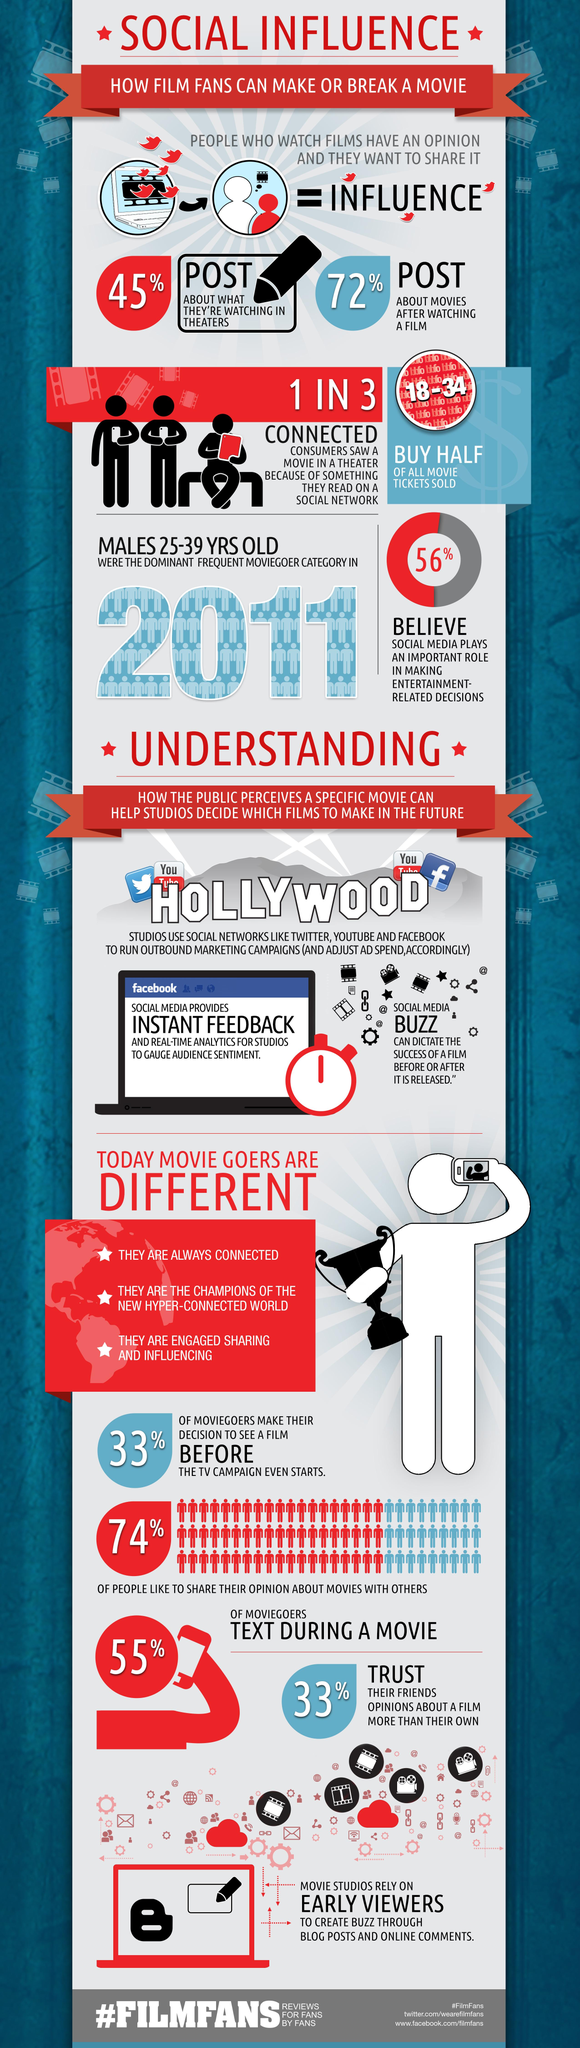Highlight a few significant elements in this photo. The 18-34 age group is responsible for purchasing half of all movie tickets sold. Approximately 26% of people do not enjoy sharing their opinions about movies with others. According to a survey, over half of the people, or 55%, do not post about the movies they watch in theaters on social media. 